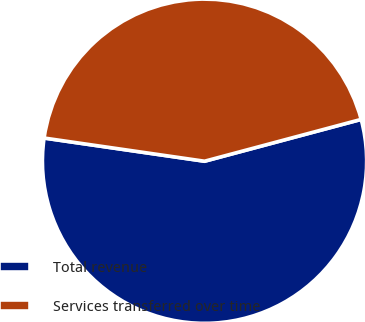<chart> <loc_0><loc_0><loc_500><loc_500><pie_chart><fcel>Total revenue<fcel>Services transferred over time<nl><fcel>56.44%<fcel>43.56%<nl></chart> 